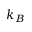<formula> <loc_0><loc_0><loc_500><loc_500>k _ { B }</formula> 